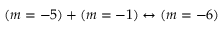Convert formula to latex. <formula><loc_0><loc_0><loc_500><loc_500>( m = - 5 ) + ( m = - 1 ) \leftrightarrow ( m = - 6 )</formula> 